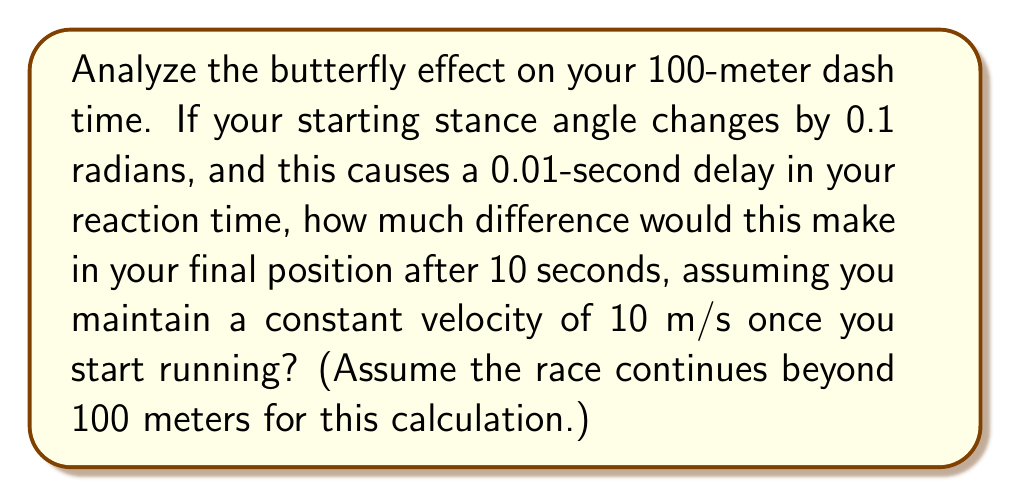Teach me how to tackle this problem. Let's approach this step-by-step:

1) First, let's calculate the distance you would run in 10 seconds without the delay:
   $$d_1 = v * t = 10 \text{ m/s} * 10 \text{ s} = 100 \text{ m}$$

2) Now, with the 0.01-second delay, you'll only be running for 9.99 seconds:
   $$d_2 = v * (t - \text{delay}) = 10 \text{ m/s} * 9.99 \text{ s} = 99.9 \text{ m}$$

3) The difference in position is:
   $$\Delta d = d_1 - d_2 = 100 \text{ m} - 99.9 \text{ m} = 0.1 \text{ m}$$

4) This might seem small, but in sprinting, 0.1 meters (10 cm) can make a significant difference. It's about the length of a hand, which could be the difference between winning and losing a close race.

5) To further illustrate the butterfly effect, we can calculate how this small initial change amplifies over time. If the race were to continue beyond 10 seconds, the difference would grow linearly:

   After 20 seconds: $\Delta d = 0.2 \text{ m}$
   After 30 seconds: $\Delta d = 0.3 \text{ m}$

   In general, after $t$ seconds: $\Delta d = 0.01t \text{ m}$

This demonstrates how a small initial change (0.1 radians in starting stance leading to 0.01 seconds delay) can lead to increasingly significant differences over time, embodying the essence of the butterfly effect in chaos theory.
Answer: 0.1 meters 